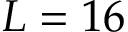<formula> <loc_0><loc_0><loc_500><loc_500>L = 1 6</formula> 